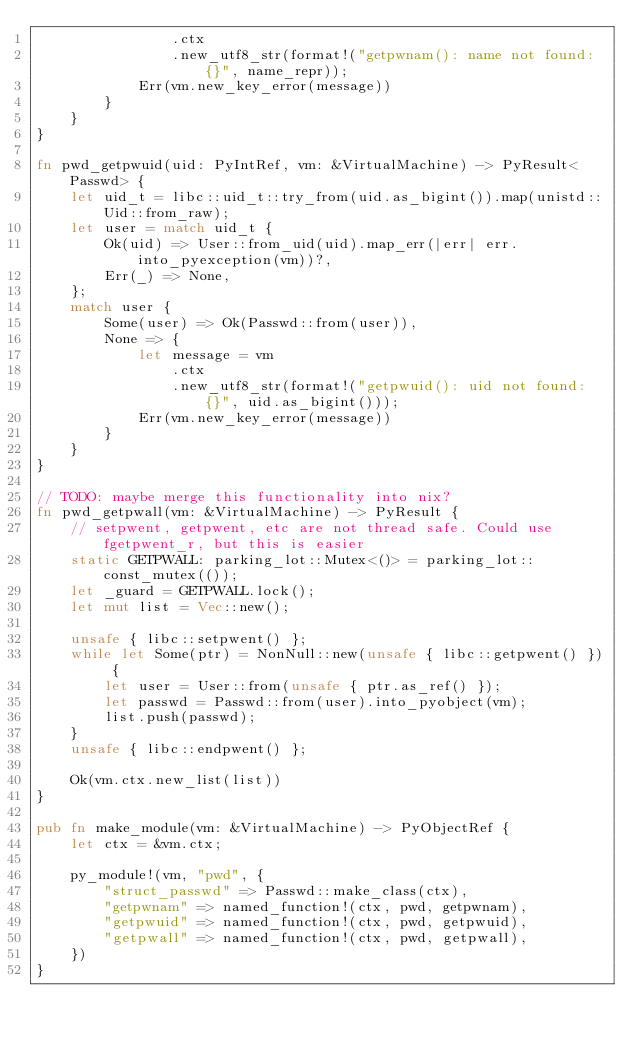Convert code to text. <code><loc_0><loc_0><loc_500><loc_500><_Rust_>                .ctx
                .new_utf8_str(format!("getpwnam(): name not found: {}", name_repr));
            Err(vm.new_key_error(message))
        }
    }
}

fn pwd_getpwuid(uid: PyIntRef, vm: &VirtualMachine) -> PyResult<Passwd> {
    let uid_t = libc::uid_t::try_from(uid.as_bigint()).map(unistd::Uid::from_raw);
    let user = match uid_t {
        Ok(uid) => User::from_uid(uid).map_err(|err| err.into_pyexception(vm))?,
        Err(_) => None,
    };
    match user {
        Some(user) => Ok(Passwd::from(user)),
        None => {
            let message = vm
                .ctx
                .new_utf8_str(format!("getpwuid(): uid not found: {}", uid.as_bigint()));
            Err(vm.new_key_error(message))
        }
    }
}

// TODO: maybe merge this functionality into nix?
fn pwd_getpwall(vm: &VirtualMachine) -> PyResult {
    // setpwent, getpwent, etc are not thread safe. Could use fgetpwent_r, but this is easier
    static GETPWALL: parking_lot::Mutex<()> = parking_lot::const_mutex(());
    let _guard = GETPWALL.lock();
    let mut list = Vec::new();

    unsafe { libc::setpwent() };
    while let Some(ptr) = NonNull::new(unsafe { libc::getpwent() }) {
        let user = User::from(unsafe { ptr.as_ref() });
        let passwd = Passwd::from(user).into_pyobject(vm);
        list.push(passwd);
    }
    unsafe { libc::endpwent() };

    Ok(vm.ctx.new_list(list))
}

pub fn make_module(vm: &VirtualMachine) -> PyObjectRef {
    let ctx = &vm.ctx;

    py_module!(vm, "pwd", {
        "struct_passwd" => Passwd::make_class(ctx),
        "getpwnam" => named_function!(ctx, pwd, getpwnam),
        "getpwuid" => named_function!(ctx, pwd, getpwuid),
        "getpwall" => named_function!(ctx, pwd, getpwall),
    })
}
</code> 